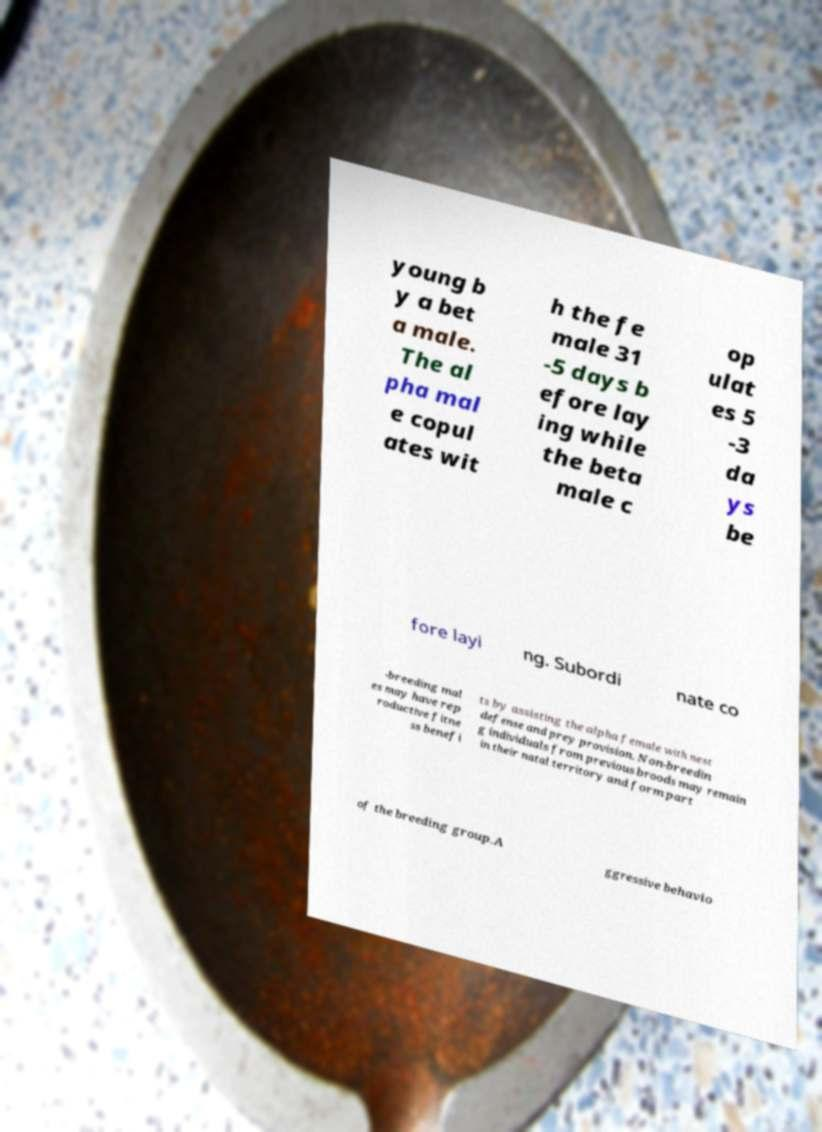Could you assist in decoding the text presented in this image and type it out clearly? young b y a bet a male. The al pha mal e copul ates wit h the fe male 31 -5 days b efore lay ing while the beta male c op ulat es 5 -3 da ys be fore layi ng. Subordi nate co -breeding mal es may have rep roductive fitne ss benefi ts by assisting the alpha female with nest defense and prey provision. Non-breedin g individuals from previous broods may remain in their natal territory and form part of the breeding group.A ggressive behavio 